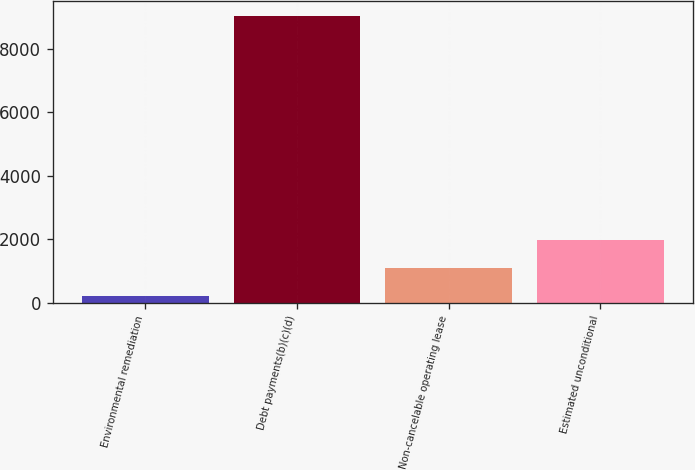<chart> <loc_0><loc_0><loc_500><loc_500><bar_chart><fcel>Environmental remediation<fcel>Debt payments(b)(c)(d)<fcel>Non-cancelable operating lease<fcel>Estimated unconditional<nl><fcel>207<fcel>9037<fcel>1090<fcel>1973<nl></chart> 